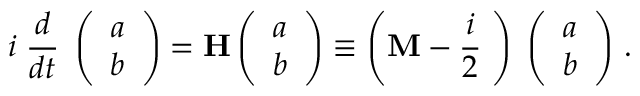Convert formula to latex. <formula><loc_0><loc_0><loc_500><loc_500>i \, \frac { d } { d t } \, \left ( \begin{array} { c } { a } \\ { b } \end{array} \right ) = { H } \left ( \begin{array} { c } { a } \\ { b } \end{array} \right ) \equiv \left ( { M } - \frac { i } { 2 } { \Gamma } \right ) \, \left ( \begin{array} { c } { a } \\ { b } \end{array} \right ) \, .</formula> 